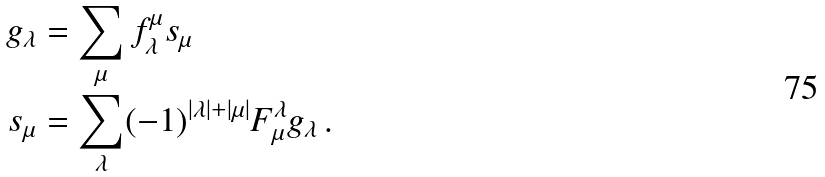Convert formula to latex. <formula><loc_0><loc_0><loc_500><loc_500>g _ { \lambda } & = \sum _ { \mu } f _ { \lambda } ^ { \mu } s _ { \mu } \\ s _ { \mu } & = \sum _ { \lambda } ( - 1 ) ^ { | \lambda | + | \mu | } F _ { \mu } ^ { \lambda } g _ { \lambda } \, .</formula> 